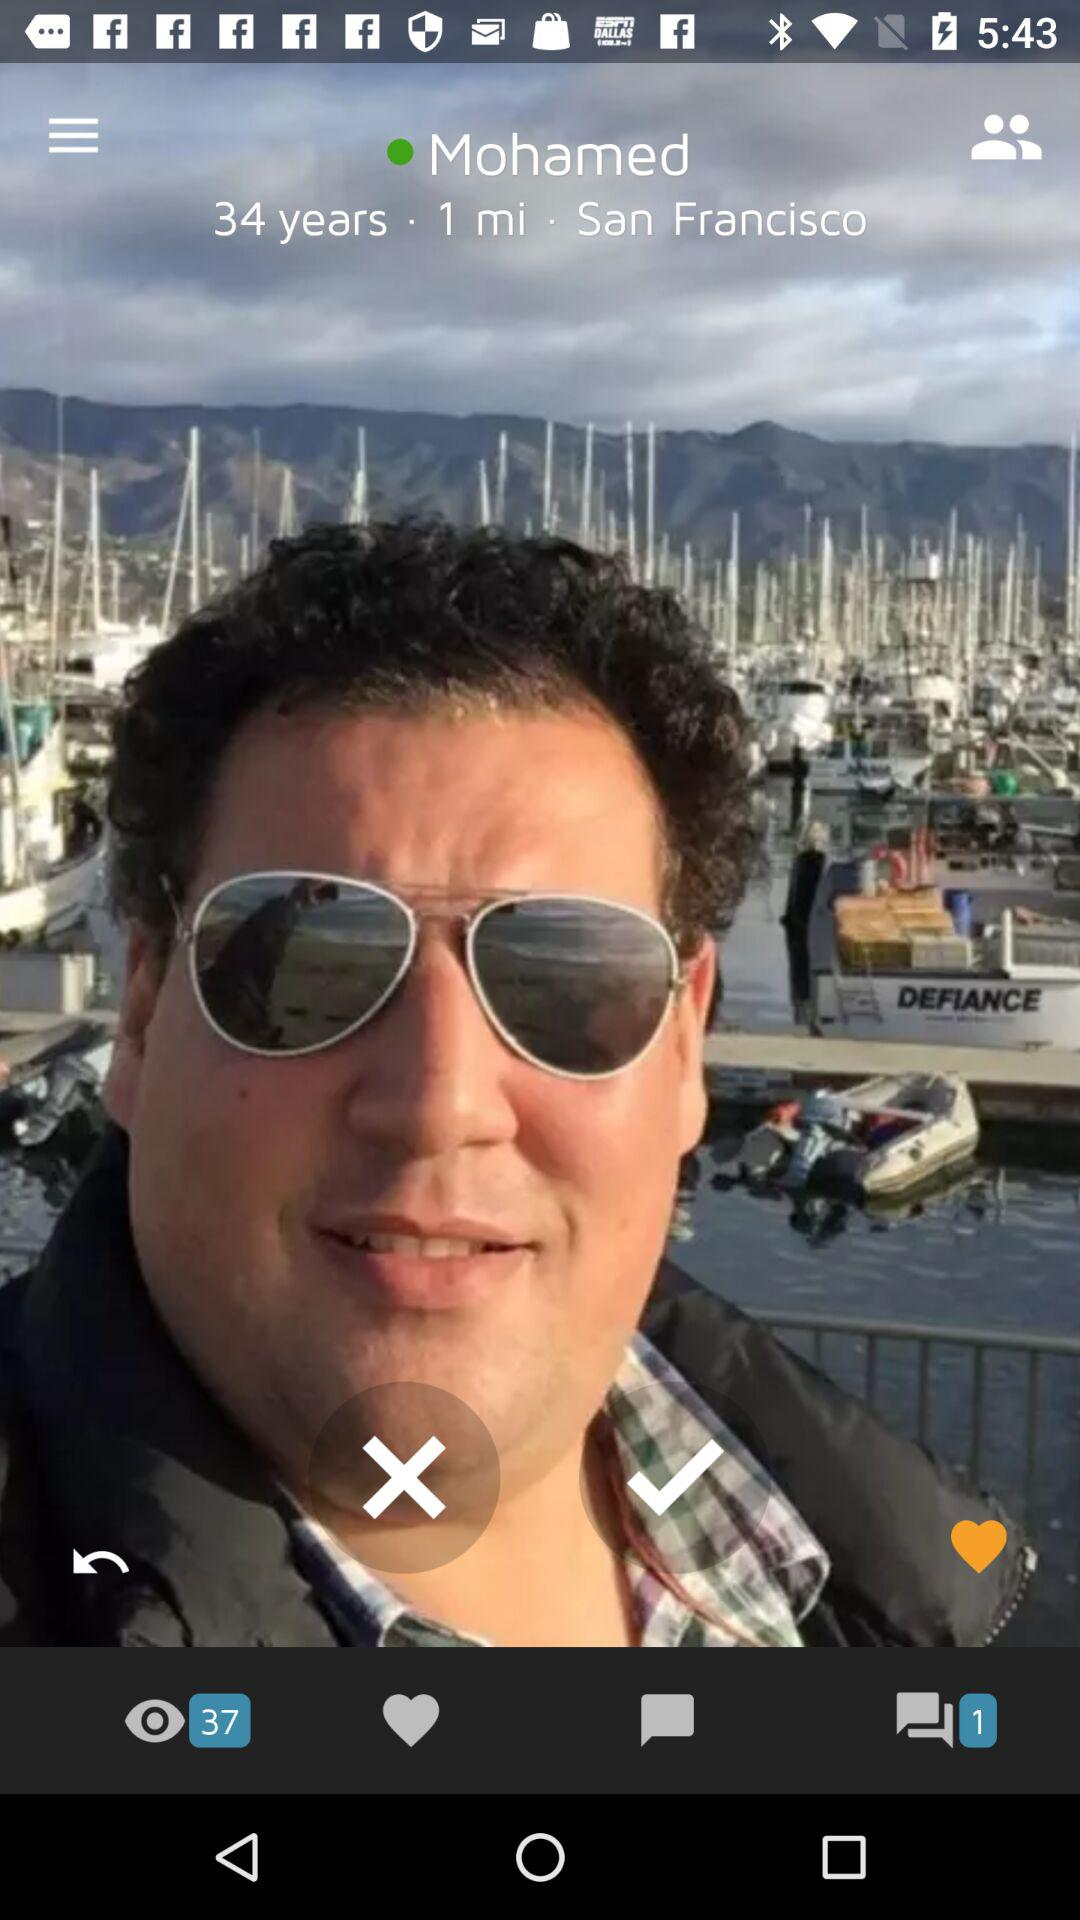What is the location? The location is San Francisco. 